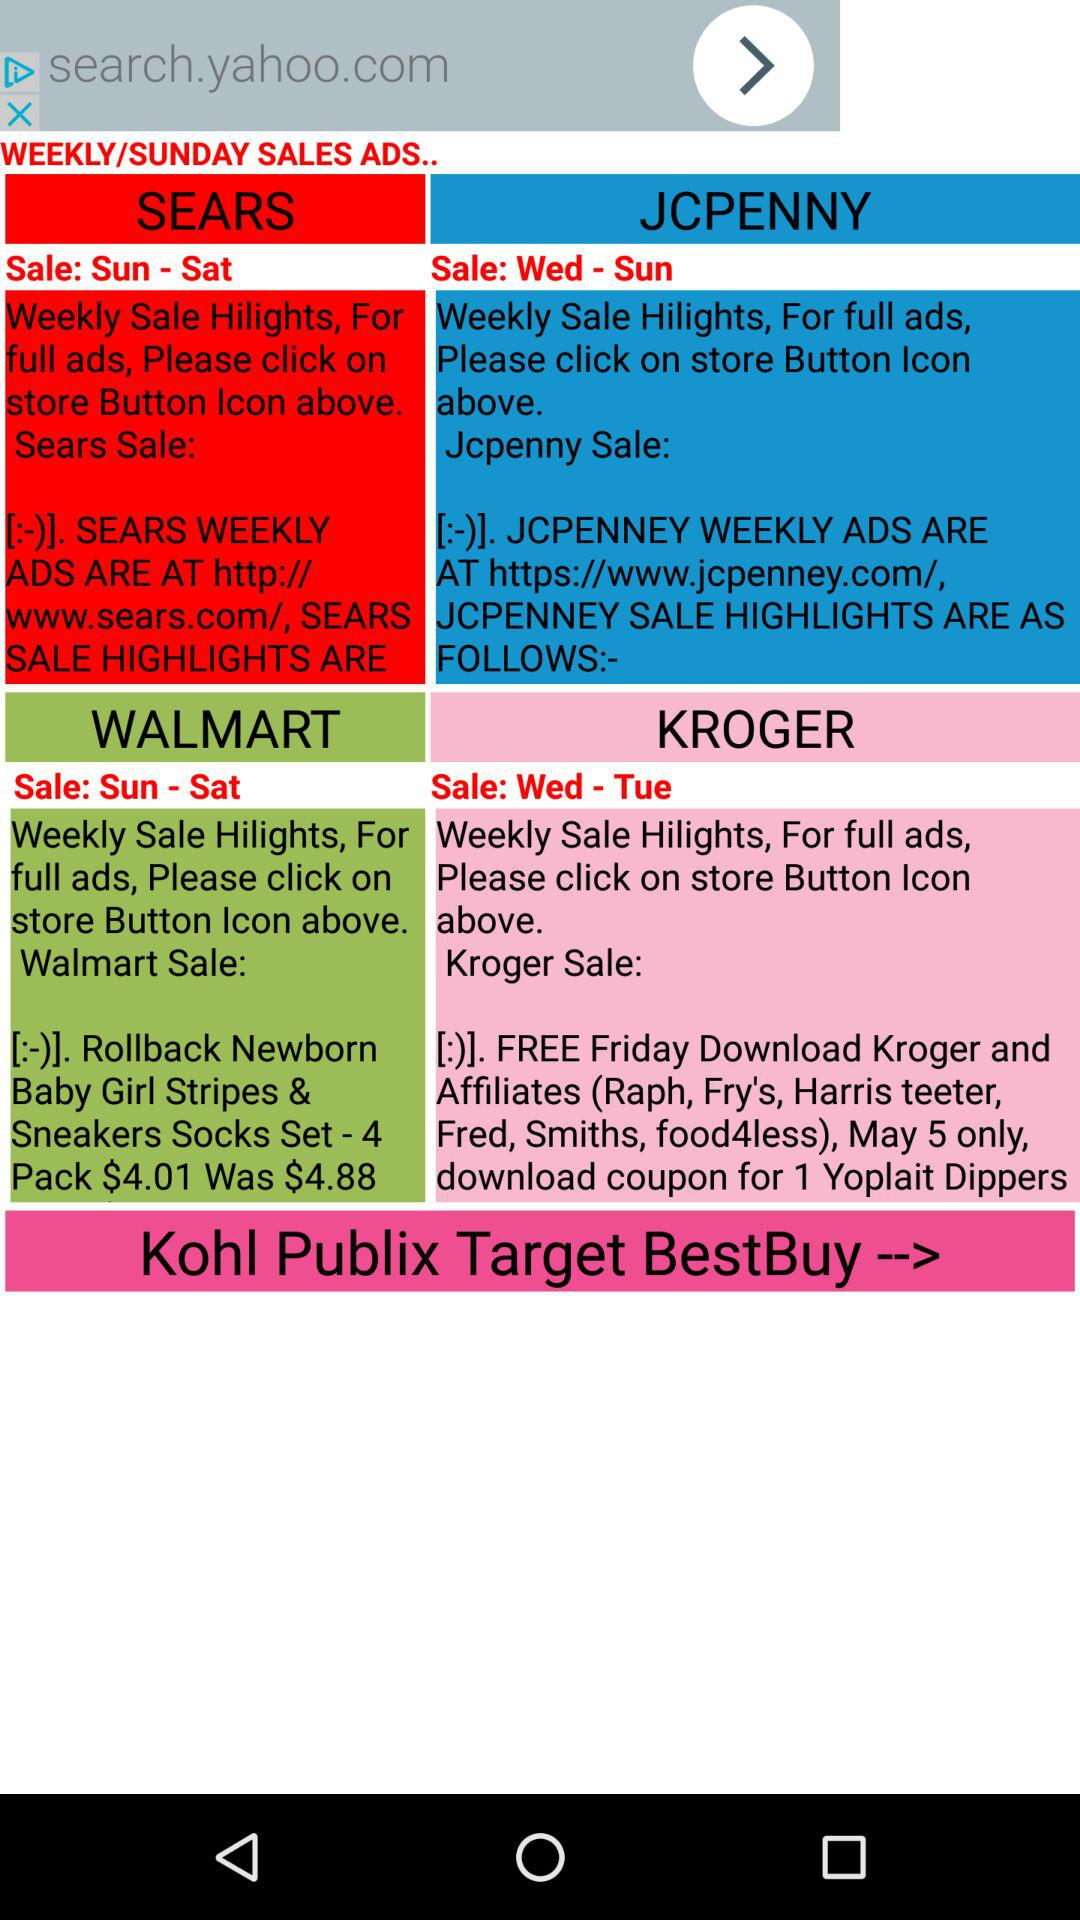How many stores have weekly ads starting on Sunday?
Answer the question using a single word or phrase. 2 